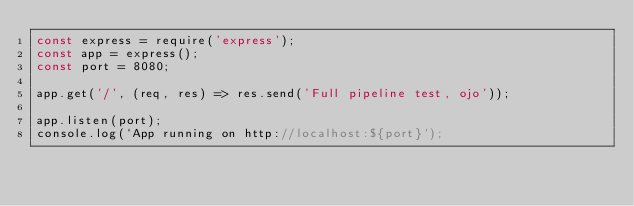Convert code to text. <code><loc_0><loc_0><loc_500><loc_500><_JavaScript_>const express = require('express');
const app = express();
const port = 8080;

app.get('/', (req, res) => res.send('Full pipeline test, ojo'));

app.listen(port);
console.log(`App running on http://localhost:${port}`);
</code> 